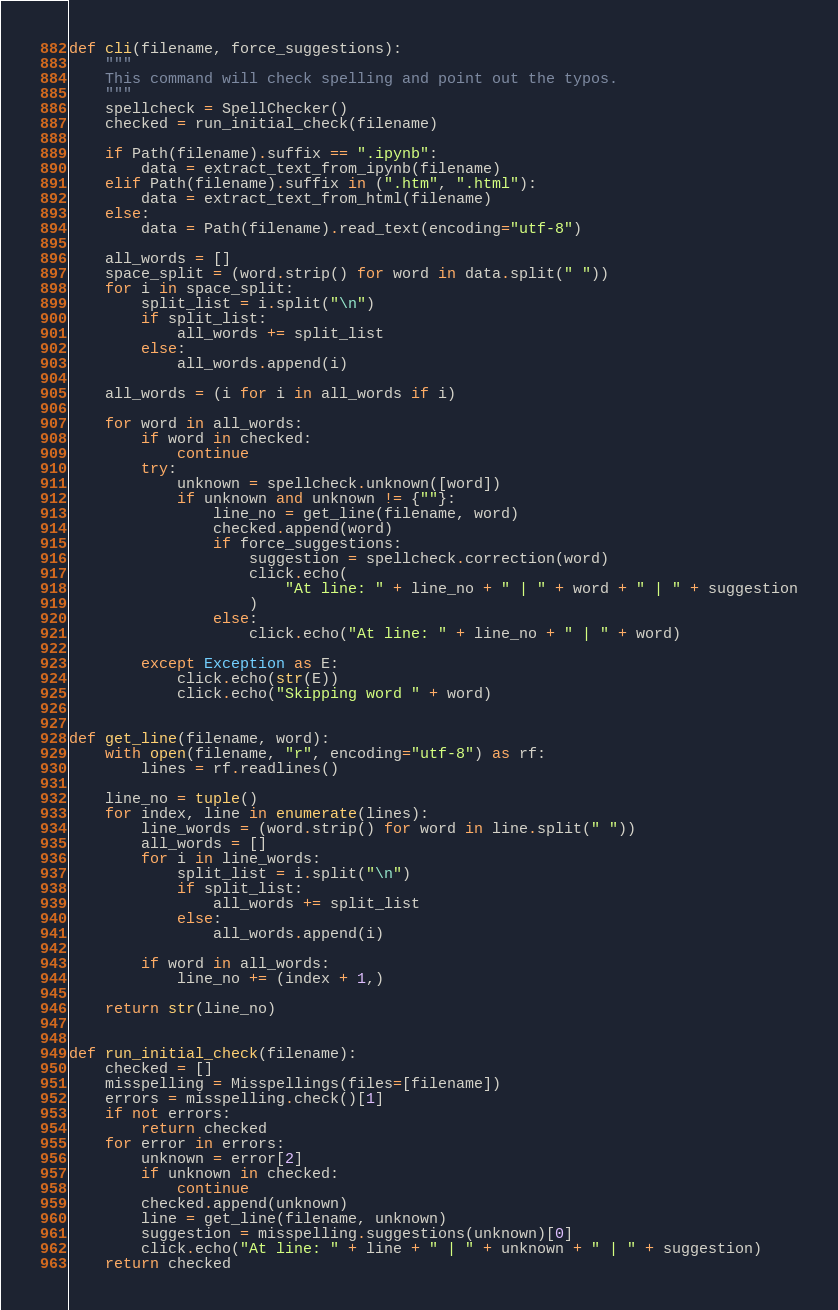<code> <loc_0><loc_0><loc_500><loc_500><_Python_>def cli(filename, force_suggestions):
    """
    This command will check spelling and point out the typos.
    """
    spellcheck = SpellChecker()
    checked = run_initial_check(filename)

    if Path(filename).suffix == ".ipynb":
        data = extract_text_from_ipynb(filename)
    elif Path(filename).suffix in (".htm", ".html"):
        data = extract_text_from_html(filename)
    else:
        data = Path(filename).read_text(encoding="utf-8")

    all_words = []
    space_split = (word.strip() for word in data.split(" "))
    for i in space_split:
        split_list = i.split("\n")
        if split_list:
            all_words += split_list
        else:
            all_words.append(i)

    all_words = (i for i in all_words if i)

    for word in all_words:
        if word in checked:
            continue
        try:
            unknown = spellcheck.unknown([word])
            if unknown and unknown != {""}:
                line_no = get_line(filename, word)
                checked.append(word)
                if force_suggestions:
                    suggestion = spellcheck.correction(word)
                    click.echo(
                        "At line: " + line_no + " | " + word + " | " + suggestion
                    )
                else:
                    click.echo("At line: " + line_no + " | " + word)

        except Exception as E:
            click.echo(str(E))
            click.echo("Skipping word " + word)


def get_line(filename, word):
    with open(filename, "r", encoding="utf-8") as rf:
        lines = rf.readlines()

    line_no = tuple()
    for index, line in enumerate(lines):
        line_words = (word.strip() for word in line.split(" "))
        all_words = []
        for i in line_words:
            split_list = i.split("\n")
            if split_list:
                all_words += split_list
            else:
                all_words.append(i)

        if word in all_words:
            line_no += (index + 1,)

    return str(line_no)


def run_initial_check(filename):
    checked = []
    misspelling = Misspellings(files=[filename])
    errors = misspelling.check()[1]
    if not errors:
        return checked
    for error in errors:
        unknown = error[2]
        if unknown in checked:
            continue
        checked.append(unknown)
        line = get_line(filename, unknown)
        suggestion = misspelling.suggestions(unknown)[0]
        click.echo("At line: " + line + " | " + unknown + " | " + suggestion)
    return checked
</code> 